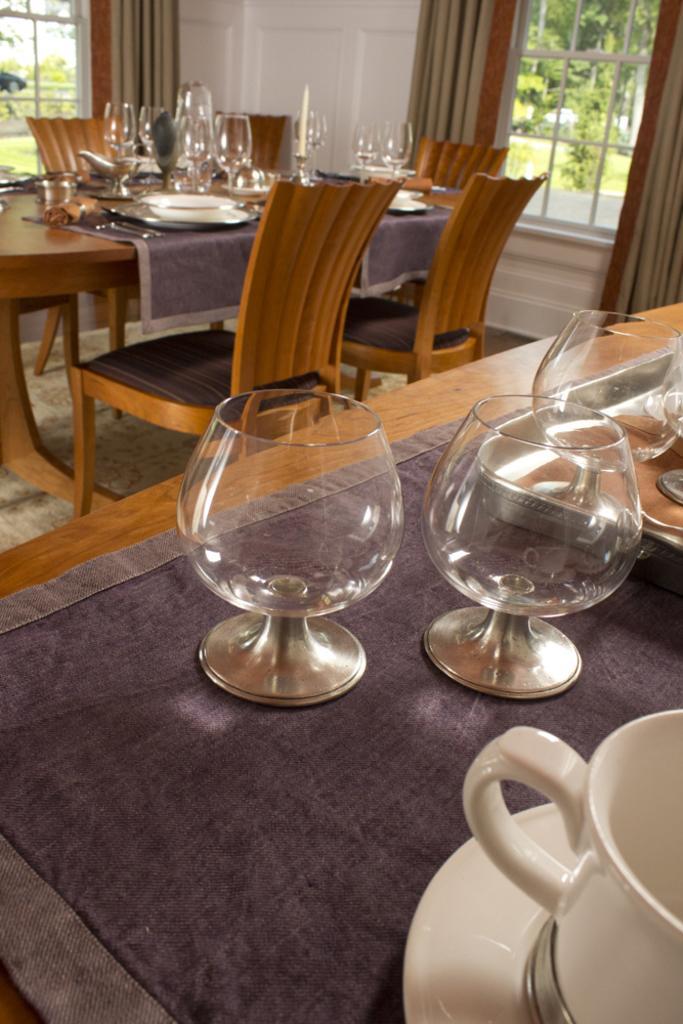Could you give a brief overview of what you see in this image? In this image I can see a table and the chairs. On the table there are glasses and the cups. At the background there are curtains to the windows. Through the windows I can see some trees. 